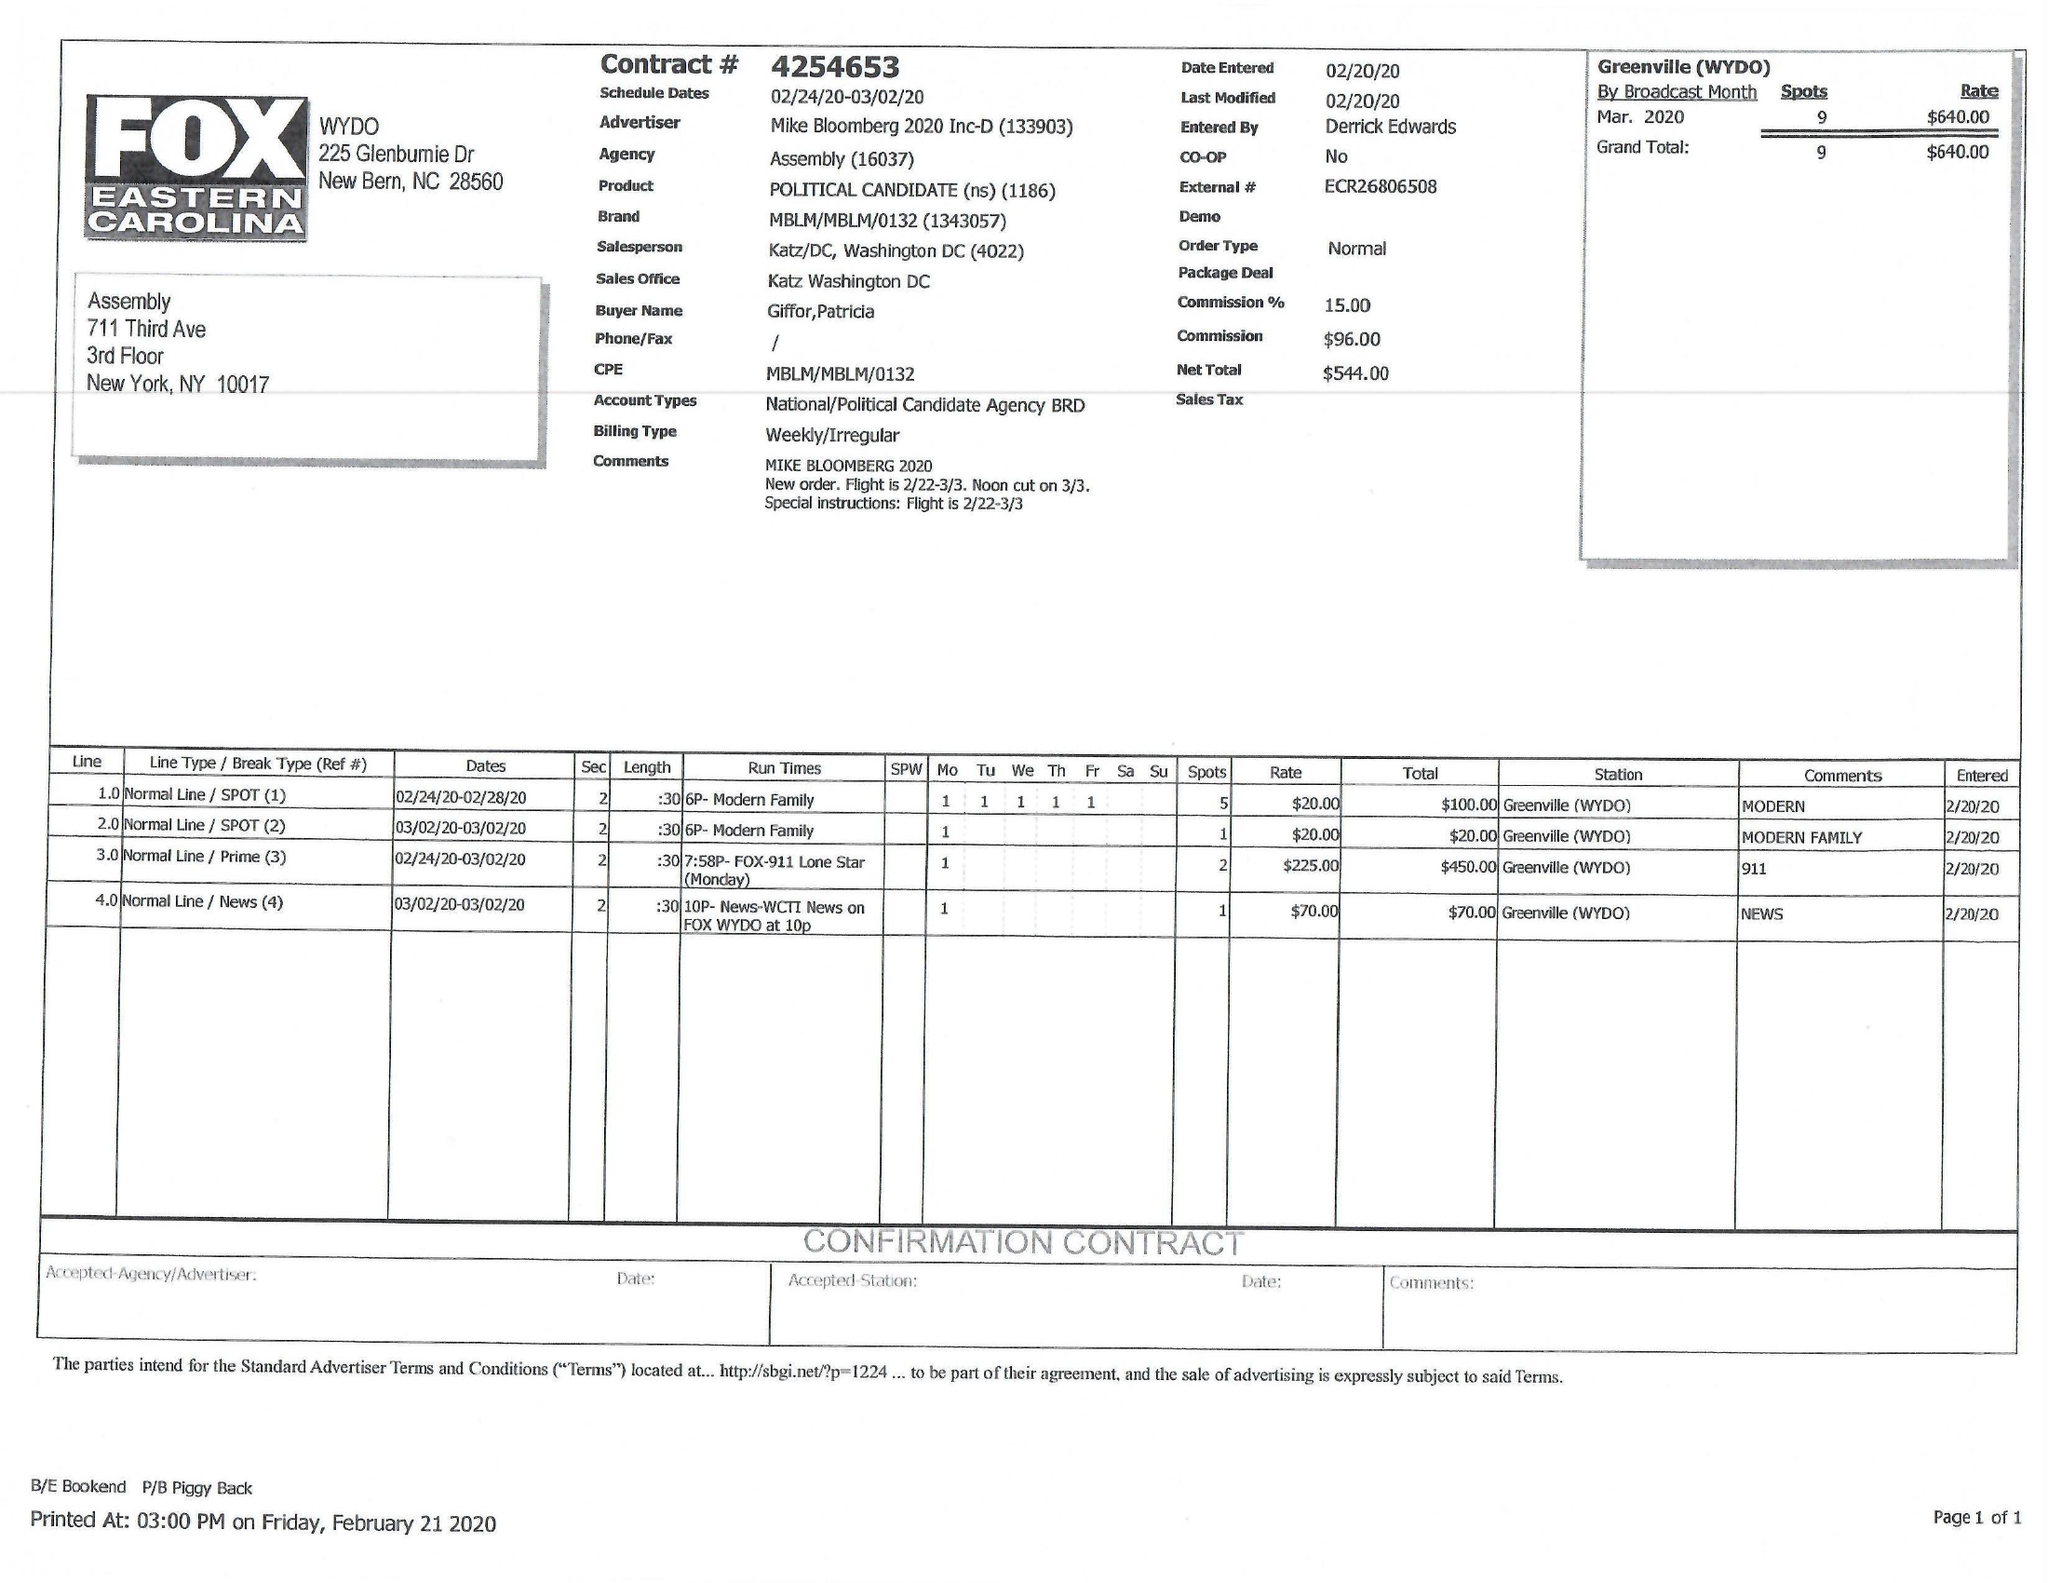What is the value for the flight_to?
Answer the question using a single word or phrase. 03/02/20 